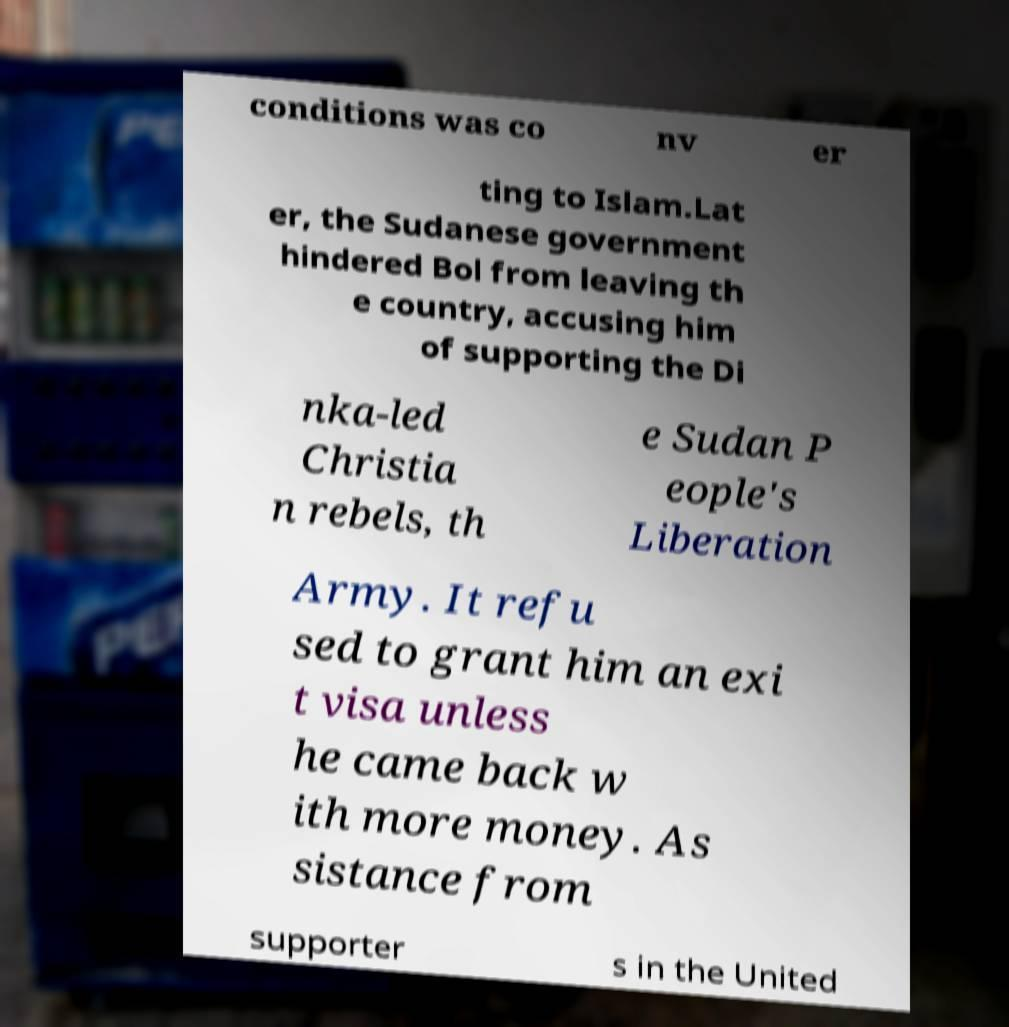I need the written content from this picture converted into text. Can you do that? conditions was co nv er ting to Islam.Lat er, the Sudanese government hindered Bol from leaving th e country, accusing him of supporting the Di nka-led Christia n rebels, th e Sudan P eople's Liberation Army. It refu sed to grant him an exi t visa unless he came back w ith more money. As sistance from supporter s in the United 